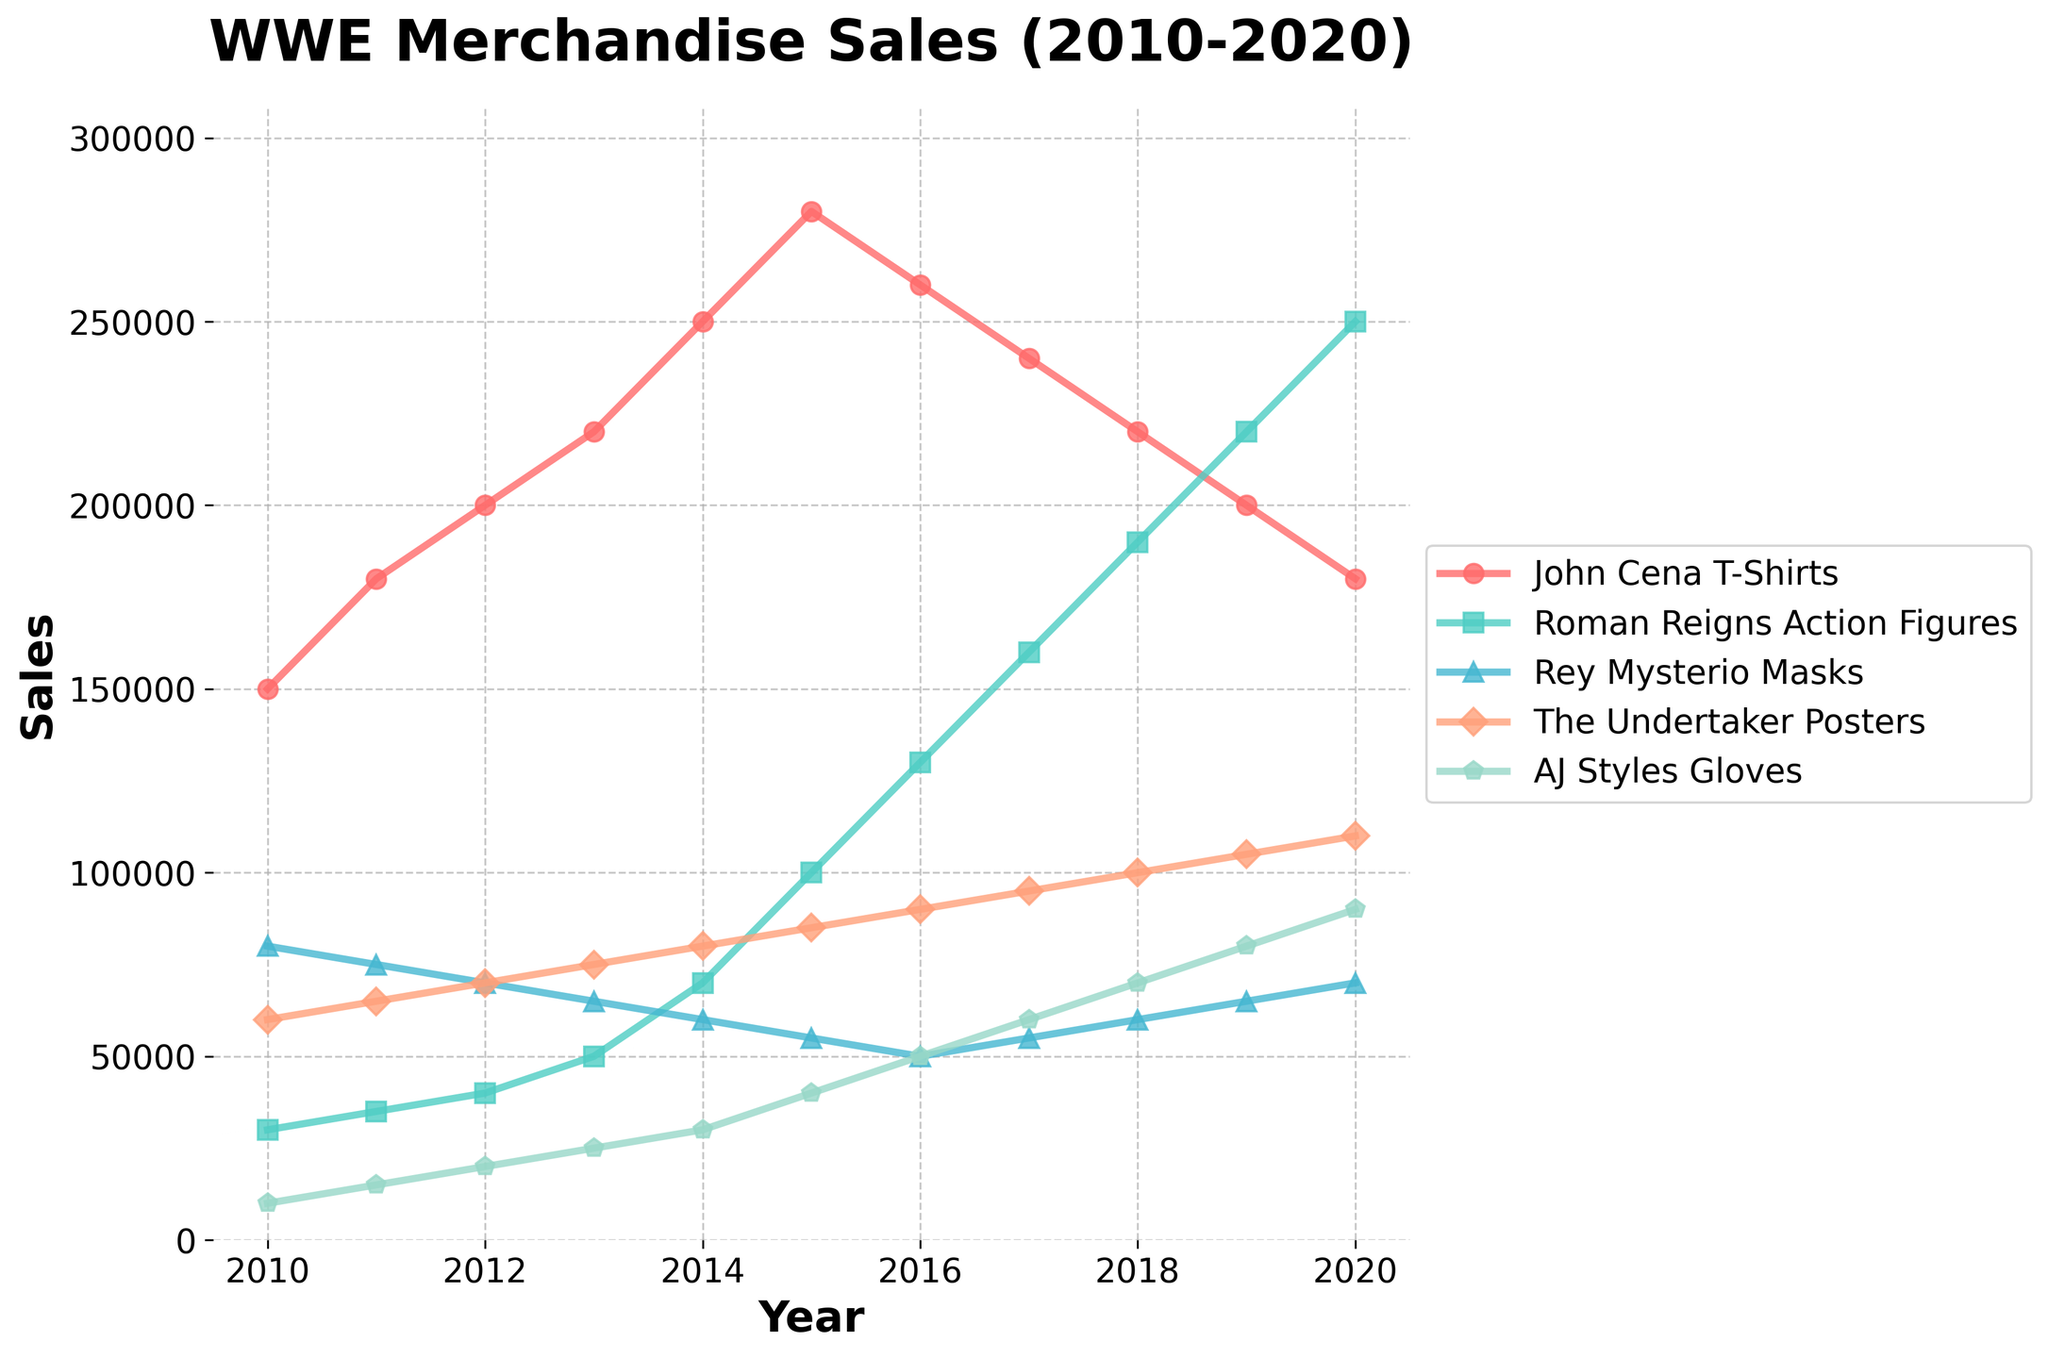What's the total sales for John Cena T-Shirts and AJ Styles Gloves in 2016? First, find the sales for John Cena T-Shirts in 2016, which is 260,000. Then, find the sales for AJ Styles Gloves in 2016, which is 50,000. Add these values together: 260,000 + 50,000 = 310,000
Answer: 310,000 Which wrestler had the highest sales in 2020? Looking at the 2020 data, the sales figures are: John Cena T-Shirts 180,000, Roman Reigns Action Figures 250,000, Rey Mysterio Masks 70,000, The Undertaker Posters 110,000, and AJ Styles Gloves 90,000. The highest number among these is 250,000 for Roman Reigns Action Figures
Answer: Roman Reigns Compare the sales trend of Rey Mysterio Masks and The Undertaker Posters from 2010 to 2020. Which product saw a greater increase? For Rey Mysterio Masks, the sales in 2010 were 80,000 and in 2020 were 70,000, which is a decrease of 10,000. For The Undertaker Posters, the sales in 2010 were 60,000 and in 2020 were 110,000, which is an increase of 50,000. The Undertaker Posters saw a greater increase
Answer: The Undertaker Posters How did the sales figures for Roman Reigns Action Figures change from 2010 to 2020? The sales for Roman Reigns Action Figures in 2010 were 30,000, and in 2020, they were 250,000. To find the change: 250,000 - 30,000 = 220,000. So, the sales increased by 220,000
Answer: Increased by 220,000 What was the average sales figure for The Undertaker Posters over the 10-year period? To find the average sales figure, add up the sales for each year and divide by the number of years: (60,000 + 65,000 + 70,000 + 75,000 + 80,000 + 85,000 + 90,000 + 95,000 + 100,000 + 105,000 + 110,000) / 11 = 85,000
Answer: 85,000 Among all product categories, which one had the highest overall sales in a single year during the 2010-2020 period? Reviewing the data, Roman Reigns Action Figures had the highest single year sales in 2020 with 250,000 units, which is higher than any other sales figure in the table
Answer: Roman Reigns Action Figures in 2020 What is the difference in sales between John Cena T-Shirts and AJ Styles Gloves in 2014? The sales for John Cena T-Shirts in 2014 were 250,000. The sales for AJ Styles Gloves in 2014 were 30,000. The difference is: 250,000 - 30,000 = 220,000
Answer: 220,000 Across the 10-year period, which product's sales showed the most steady increase? By observing the trends, Roman Reigns Action Figures show a consistent increase every year without any declines, indicating the most steady increase
Answer: Roman Reigns Action Figures What is the sales trend for John Cena T-Shirts from 2015 to 2020? From 2015 to 2016, sales decreased from 280,000 to 260,000. From 2016 to 2017, sales decreased again to 240,000. The trend continued to decline with 220,000 in 2018, 200,000 in 2019, and finally 180,000 in 2020. Thus, the trend is a continuous decrease
Answer: Continuous decrease 